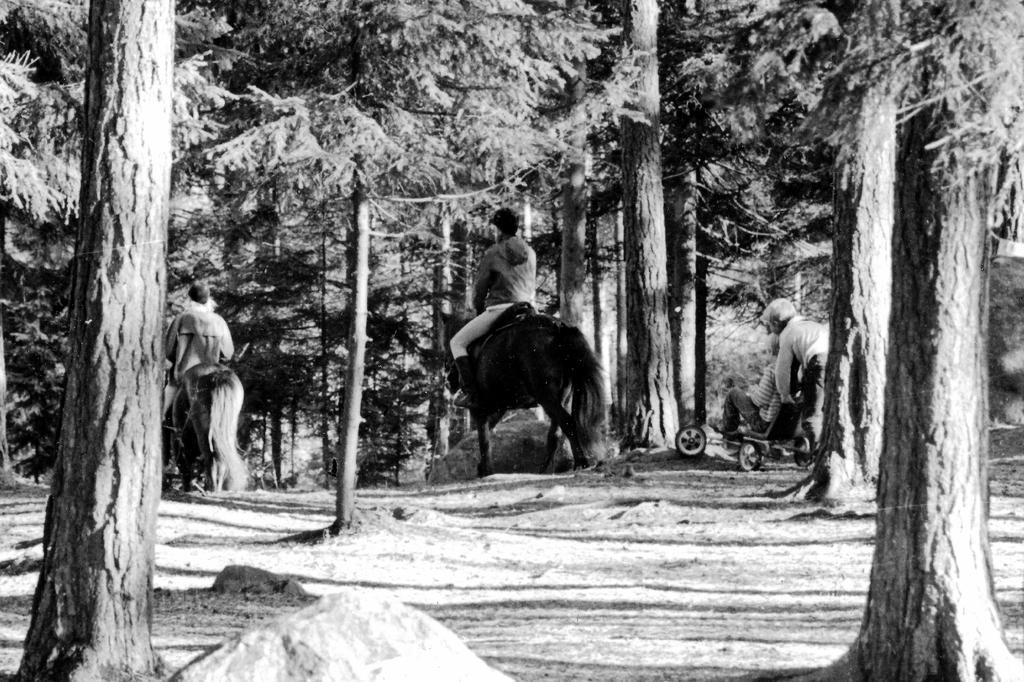Could you give a brief overview of what you see in this image? This picture shows that some men are riding horses. One guy is in trolley and the other one is pushing the trolley. We can observe some land and trees in the background here. 